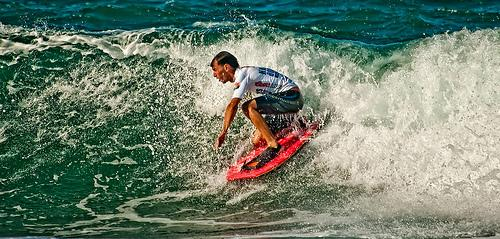Explain the surfer's appearance in a casual manner. This dude on the red surfboard has dark hair, blue shorts, and a white t-shirt with some writing on it. What color contrasts are depicted in the image that make it eye-catching? The eye-catching contrasts comprise the red surfboard, blue water, white waves, and the surfer's blue shorts. Give a brief description of the image highlighting the surfer's stance. A surfer crouches down on a red surfboard, arms in front, riding a big wave with a focused expression. Describe the scene by mentioning key colors and objects in the foreground and background. In a daytime setting, a man surfs on red board, wearing blue shorts and white top, amidst blue water and white waves. Narrate what the man in the image is doing, focusing on his outfit and surfboard color. A man with dark hair is surfing on a red surfboard, wearing a white top with writing and blue shorts. Talk about the surfer's style while riding the wave. The surfer, wearing a white top with an emblem and blue shorts, stylishly rides a red surfboard on the ocean wave. Compose a poetic expression to narrate the image. Upon the mighty ocean's hue of greenish blue, a surfer claims his ride on a red board as white waves bloom. Describe the image emphasizing the water and wave details. The ocean is a captivating greenish-blue color, filled with white foam and large waves on which a man is surfing. What are the most prominent elements in the photo related to nature? The greenish-blue ocean water with white capped waves showcases nature's beauty as the man surfs. Mention the primary activity and colors noticed in the image. A man is surfing on a red board amidst blue water and white waves, wearing a white top and blue shorts. 